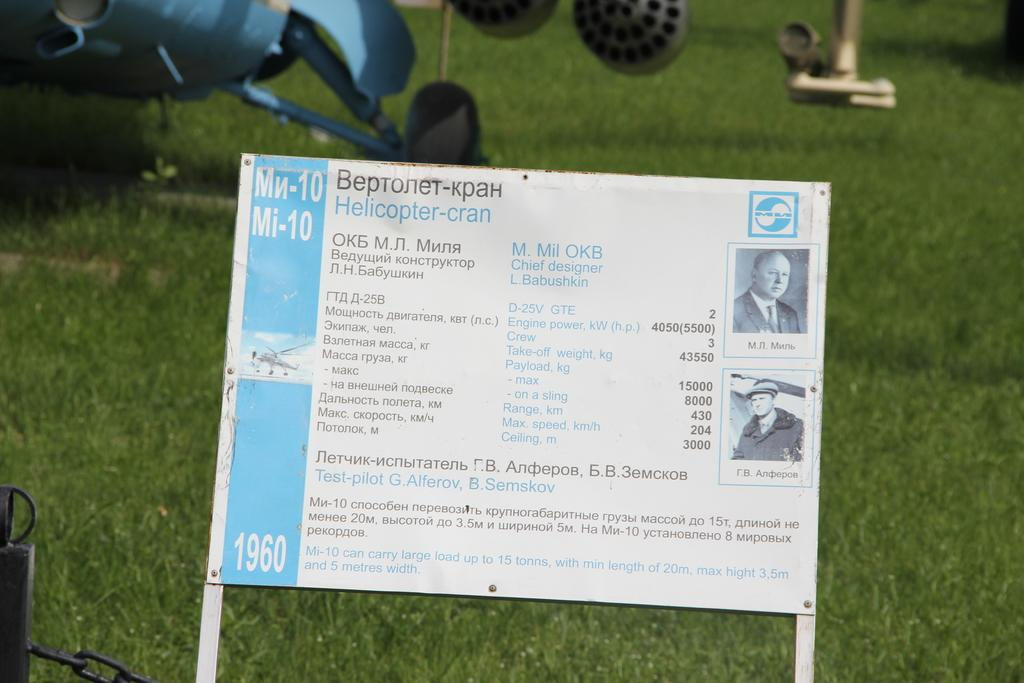What is the main structure in the image? There is a board on two poles in the image. What can be seen in the background of the image? There is an object on the grass in the background. What is connected to an object on the left side of the image? There is a chain attached to an object on the left side of the image. What type of salt is being used to season the tree in the image? There is no salt or tree present in the image. What color is the sweater worn by the person in the image? There is no person or sweater present in the image. 